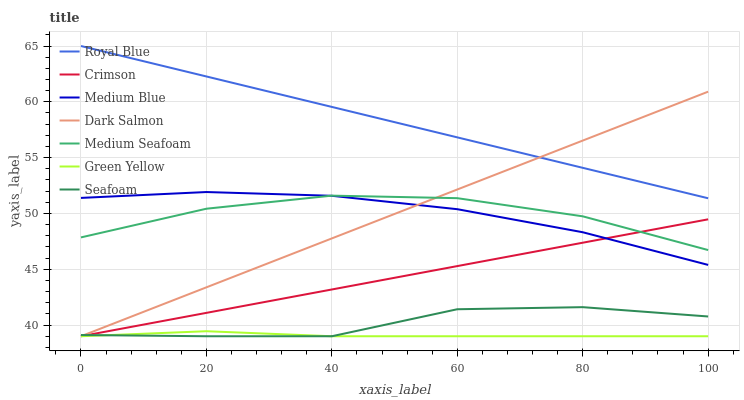Does Green Yellow have the minimum area under the curve?
Answer yes or no. Yes. Does Royal Blue have the maximum area under the curve?
Answer yes or no. Yes. Does Dark Salmon have the minimum area under the curve?
Answer yes or no. No. Does Dark Salmon have the maximum area under the curve?
Answer yes or no. No. Is Royal Blue the smoothest?
Answer yes or no. Yes. Is Seafoam the roughest?
Answer yes or no. Yes. Is Dark Salmon the smoothest?
Answer yes or no. No. Is Dark Salmon the roughest?
Answer yes or no. No. Does Dark Salmon have the lowest value?
Answer yes or no. Yes. Does Royal Blue have the lowest value?
Answer yes or no. No. Does Royal Blue have the highest value?
Answer yes or no. Yes. Does Dark Salmon have the highest value?
Answer yes or no. No. Is Seafoam less than Royal Blue?
Answer yes or no. Yes. Is Medium Blue greater than Green Yellow?
Answer yes or no. Yes. Does Green Yellow intersect Crimson?
Answer yes or no. Yes. Is Green Yellow less than Crimson?
Answer yes or no. No. Is Green Yellow greater than Crimson?
Answer yes or no. No. Does Seafoam intersect Royal Blue?
Answer yes or no. No. 